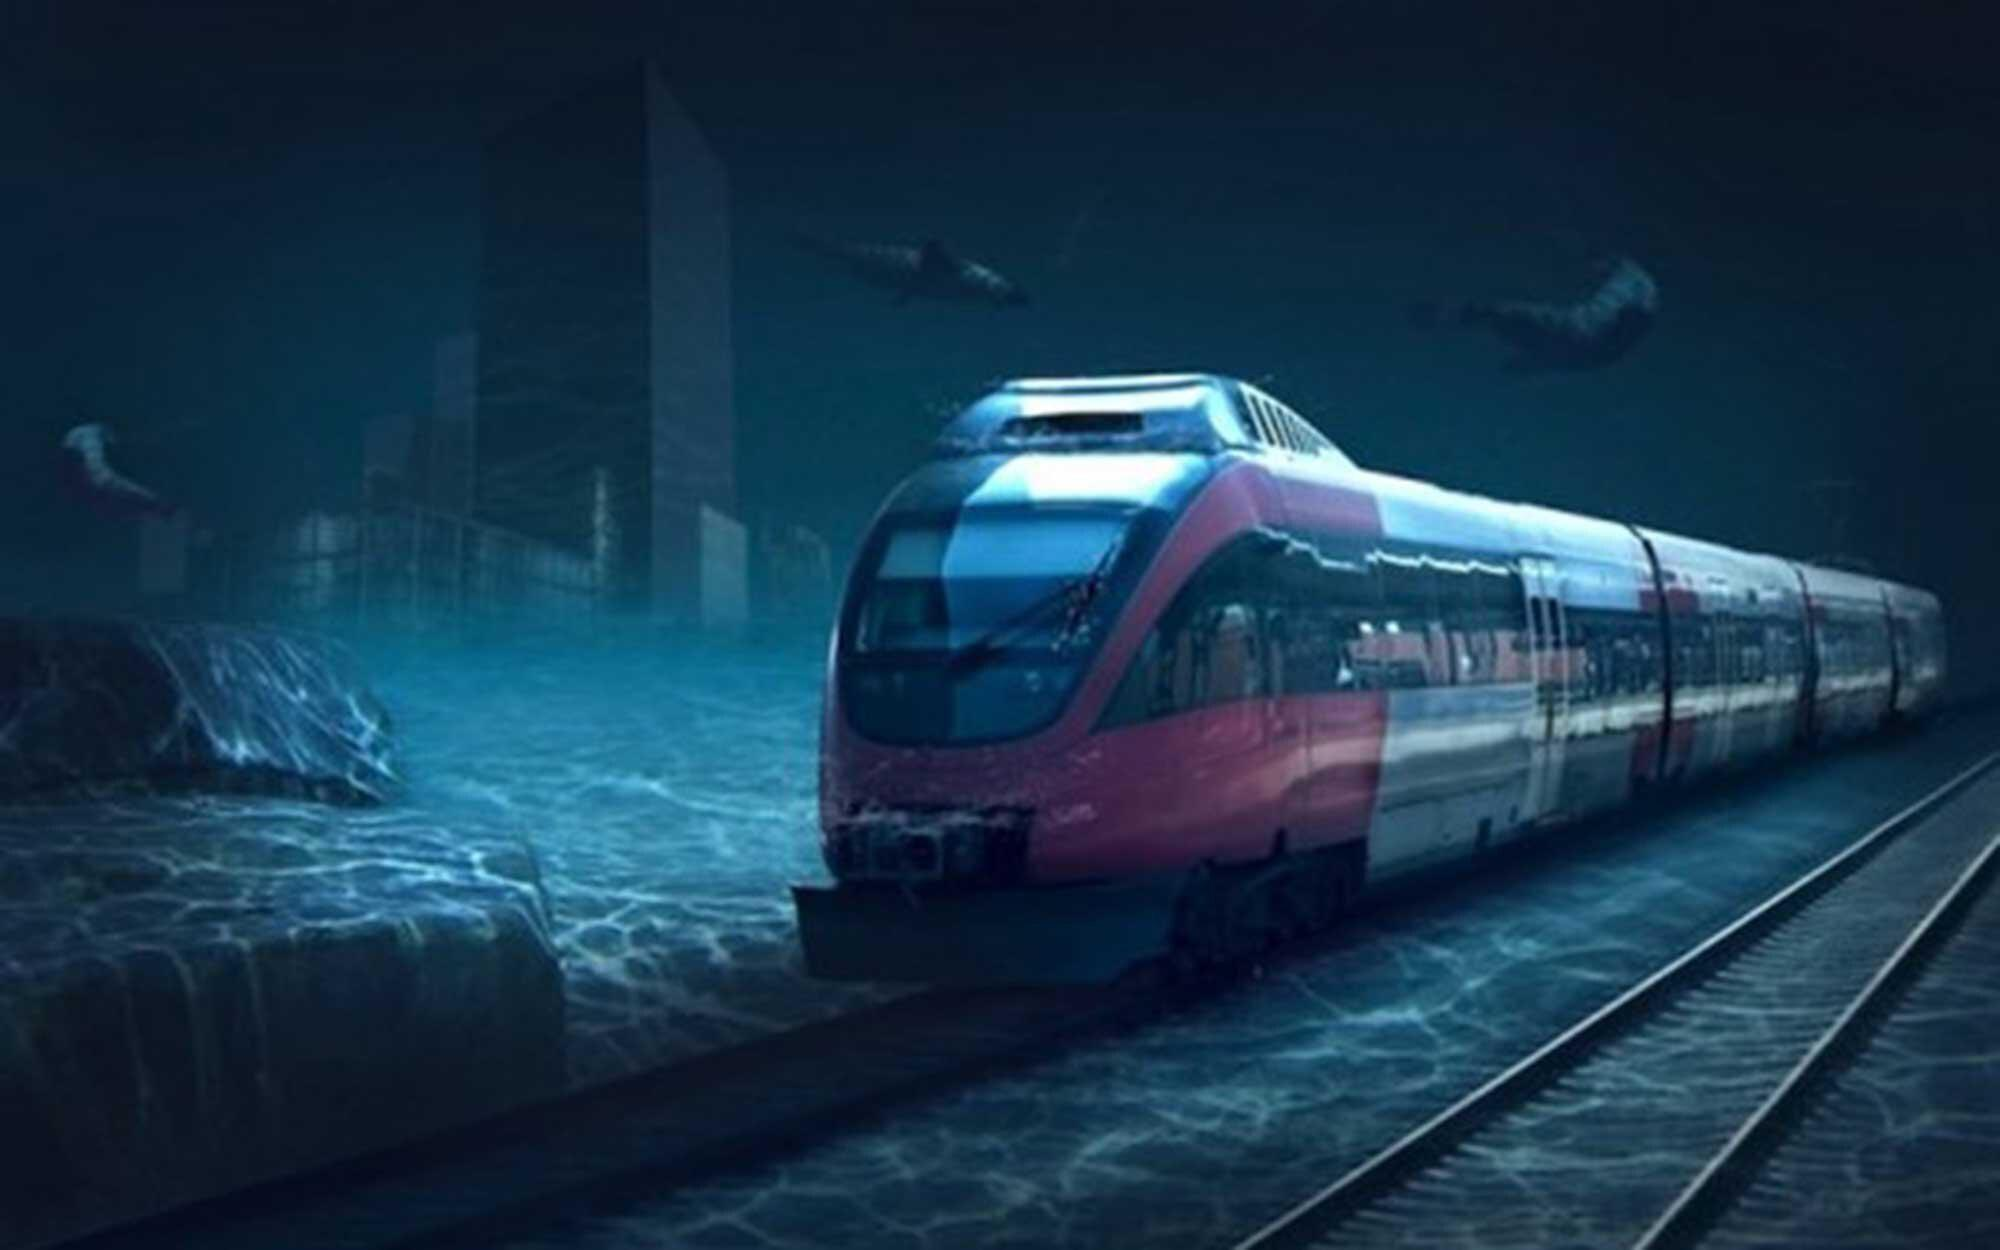Is there a train in the image? Yes 